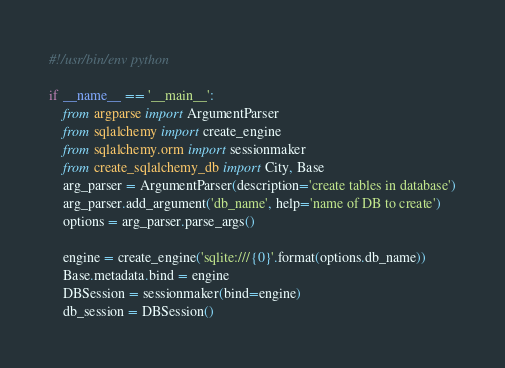Convert code to text. <code><loc_0><loc_0><loc_500><loc_500><_Python_>#!/usr/bin/env python

if __name__ == '__main__':
    from argparse import ArgumentParser
    from sqlalchemy import create_engine
    from sqlalchemy.orm import sessionmaker
    from create_sqlalchemy_db import City, Base
    arg_parser = ArgumentParser(description='create tables in database')
    arg_parser.add_argument('db_name', help='name of DB to create')
    options = arg_parser.parse_args()

    engine = create_engine('sqlite:///{0}'.format(options.db_name))
    Base.metadata.bind = engine
    DBSession = sessionmaker(bind=engine)
    db_session = DBSession()</code> 